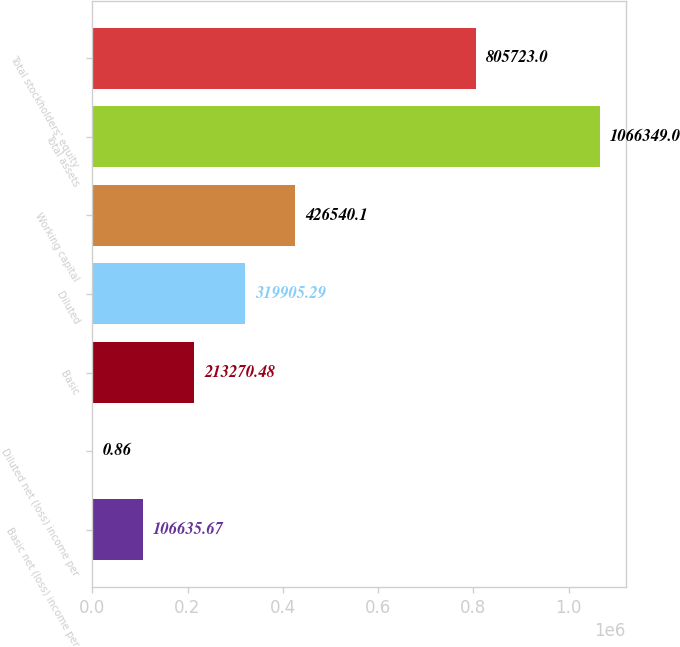Convert chart. <chart><loc_0><loc_0><loc_500><loc_500><bar_chart><fcel>Basic net (loss) income per<fcel>Diluted net (loss) income per<fcel>Basic<fcel>Diluted<fcel>Working capital<fcel>Total assets<fcel>Total stockholders' equity<nl><fcel>106636<fcel>0.86<fcel>213270<fcel>319905<fcel>426540<fcel>1.06635e+06<fcel>805723<nl></chart> 